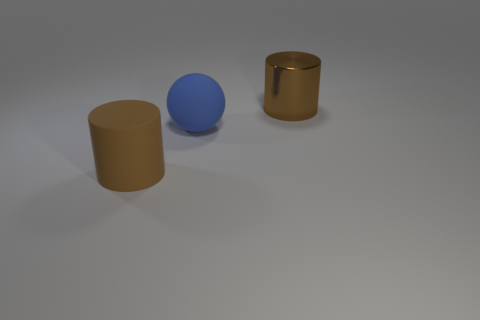Add 1 big yellow metallic cylinders. How many objects exist? 4 Subtract all balls. How many objects are left? 2 Add 1 small brown shiny blocks. How many small brown shiny blocks exist? 1 Subtract 1 brown cylinders. How many objects are left? 2 Subtract all small matte spheres. Subtract all big brown shiny cylinders. How many objects are left? 2 Add 1 big blue rubber things. How many big blue rubber things are left? 2 